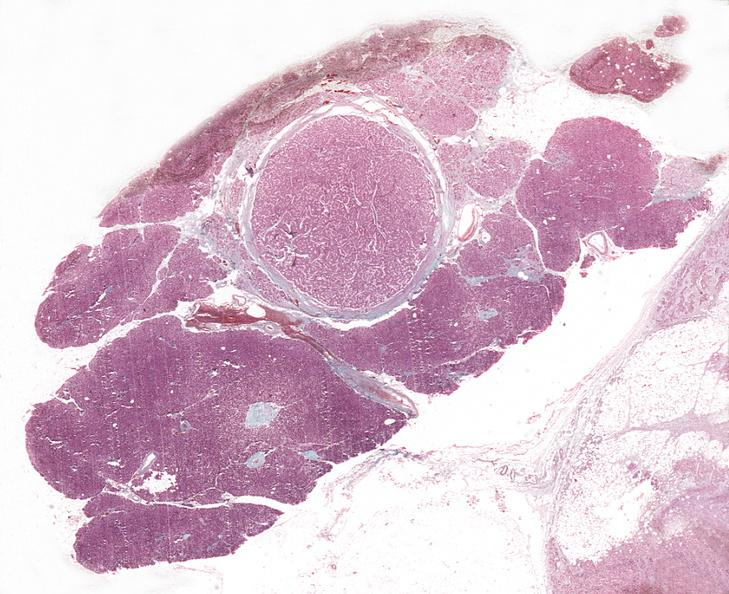what does this image show?
Answer the question using a single word or phrase. Islet cell adenoma 